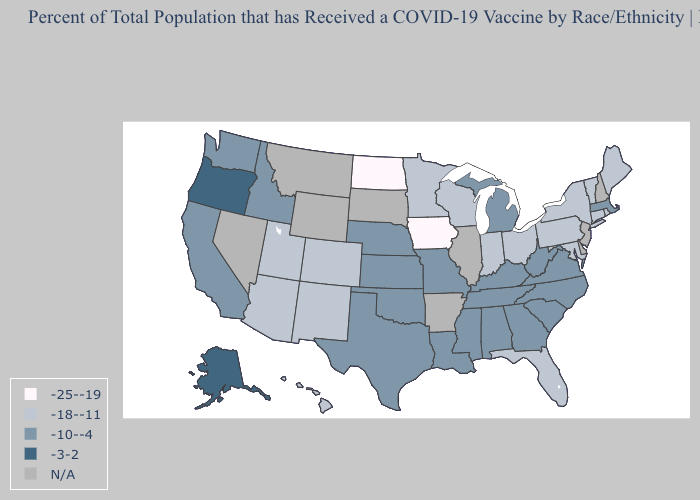Name the states that have a value in the range -10--4?
Write a very short answer. Alabama, California, Georgia, Idaho, Kansas, Kentucky, Louisiana, Massachusetts, Michigan, Mississippi, Missouri, Nebraska, North Carolina, Oklahoma, South Carolina, Tennessee, Texas, Virginia, Washington, West Virginia. Among the states that border Michigan , which have the highest value?
Quick response, please. Indiana, Ohio, Wisconsin. What is the value of Missouri?
Be succinct. -10--4. What is the value of Tennessee?
Concise answer only. -10--4. Among the states that border Kansas , does Missouri have the highest value?
Give a very brief answer. Yes. Does Alaska have the highest value in the USA?
Be succinct. Yes. Which states have the lowest value in the USA?
Quick response, please. Iowa, North Dakota. Which states have the lowest value in the Northeast?
Quick response, please. Connecticut, Maine, New York, Pennsylvania, Rhode Island, Vermont. Name the states that have a value in the range -3-2?
Short answer required. Alaska, Oregon. Is the legend a continuous bar?
Be succinct. No. Which states have the highest value in the USA?
Quick response, please. Alaska, Oregon. What is the value of Kentucky?
Be succinct. -10--4. Among the states that border Kentucky , which have the lowest value?
Give a very brief answer. Indiana, Ohio. What is the value of Virginia?
Be succinct. -10--4. 